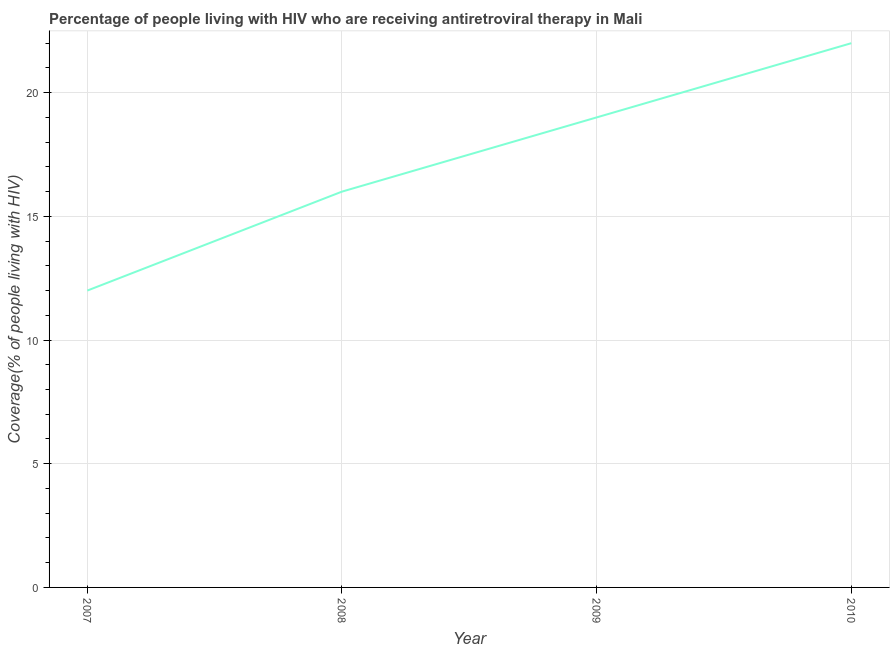What is the antiretroviral therapy coverage in 2009?
Your response must be concise. 19. Across all years, what is the maximum antiretroviral therapy coverage?
Ensure brevity in your answer.  22. Across all years, what is the minimum antiretroviral therapy coverage?
Your answer should be very brief. 12. In which year was the antiretroviral therapy coverage maximum?
Keep it short and to the point. 2010. In which year was the antiretroviral therapy coverage minimum?
Provide a succinct answer. 2007. What is the sum of the antiretroviral therapy coverage?
Your response must be concise. 69. What is the difference between the antiretroviral therapy coverage in 2008 and 2010?
Your answer should be compact. -6. What is the average antiretroviral therapy coverage per year?
Your response must be concise. 17.25. In how many years, is the antiretroviral therapy coverage greater than 1 %?
Your answer should be very brief. 4. What is the ratio of the antiretroviral therapy coverage in 2007 to that in 2010?
Offer a terse response. 0.55. Is the antiretroviral therapy coverage in 2007 less than that in 2008?
Keep it short and to the point. Yes. What is the difference between the highest and the second highest antiretroviral therapy coverage?
Offer a very short reply. 3. Is the sum of the antiretroviral therapy coverage in 2008 and 2009 greater than the maximum antiretroviral therapy coverage across all years?
Make the answer very short. Yes. What is the difference between the highest and the lowest antiretroviral therapy coverage?
Give a very brief answer. 10. In how many years, is the antiretroviral therapy coverage greater than the average antiretroviral therapy coverage taken over all years?
Give a very brief answer. 2. What is the title of the graph?
Provide a succinct answer. Percentage of people living with HIV who are receiving antiretroviral therapy in Mali. What is the label or title of the X-axis?
Ensure brevity in your answer.  Year. What is the label or title of the Y-axis?
Offer a very short reply. Coverage(% of people living with HIV). What is the difference between the Coverage(% of people living with HIV) in 2008 and 2009?
Keep it short and to the point. -3. What is the ratio of the Coverage(% of people living with HIV) in 2007 to that in 2008?
Your answer should be very brief. 0.75. What is the ratio of the Coverage(% of people living with HIV) in 2007 to that in 2009?
Your answer should be very brief. 0.63. What is the ratio of the Coverage(% of people living with HIV) in 2007 to that in 2010?
Provide a short and direct response. 0.55. What is the ratio of the Coverage(% of people living with HIV) in 2008 to that in 2009?
Your answer should be compact. 0.84. What is the ratio of the Coverage(% of people living with HIV) in 2008 to that in 2010?
Provide a succinct answer. 0.73. What is the ratio of the Coverage(% of people living with HIV) in 2009 to that in 2010?
Your response must be concise. 0.86. 